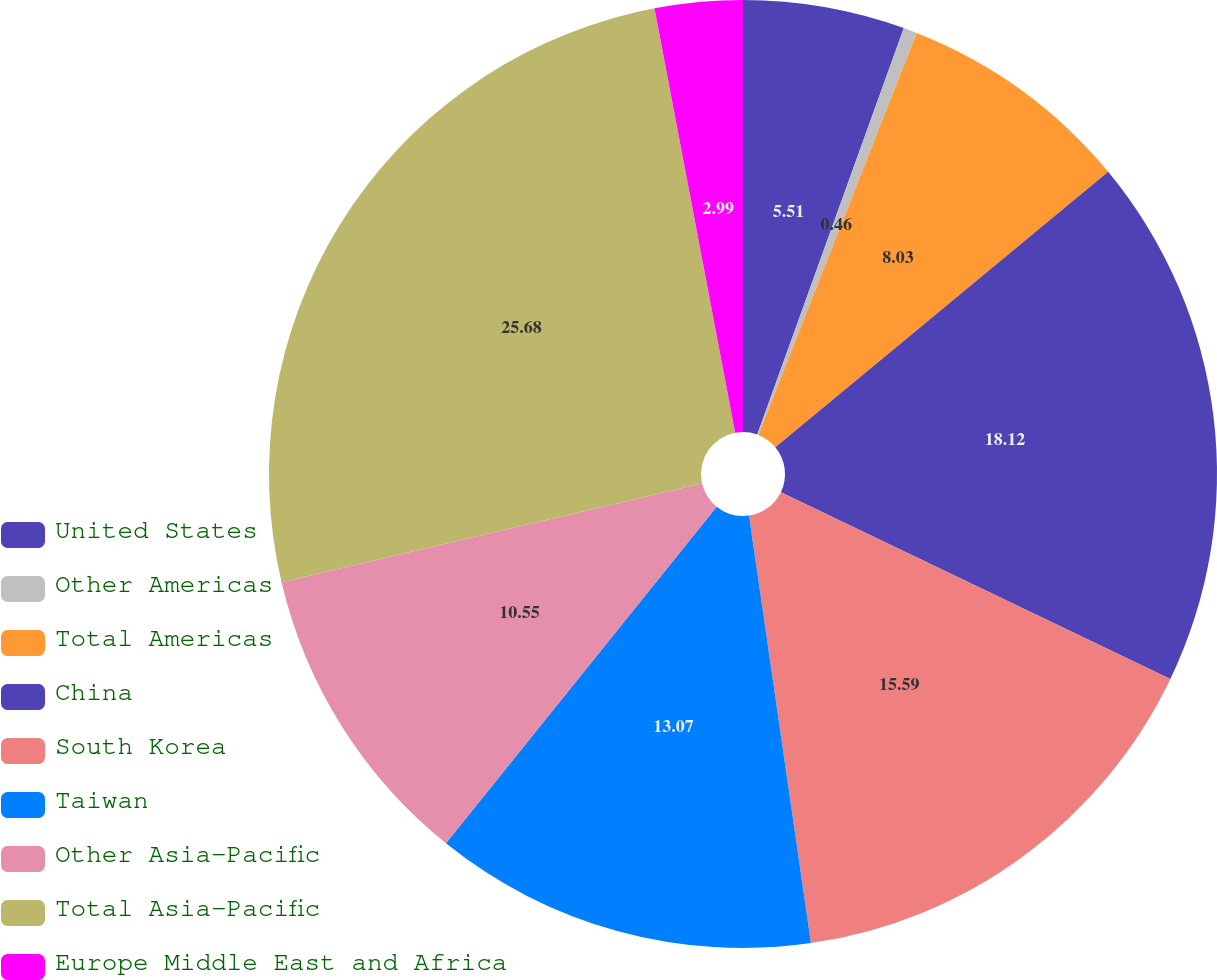Convert chart to OTSL. <chart><loc_0><loc_0><loc_500><loc_500><pie_chart><fcel>United States<fcel>Other Americas<fcel>Total Americas<fcel>China<fcel>South Korea<fcel>Taiwan<fcel>Other Asia-Pacific<fcel>Total Asia-Pacific<fcel>Europe Middle East and Africa<nl><fcel>5.51%<fcel>0.46%<fcel>8.03%<fcel>18.12%<fcel>15.59%<fcel>13.07%<fcel>10.55%<fcel>25.68%<fcel>2.99%<nl></chart> 